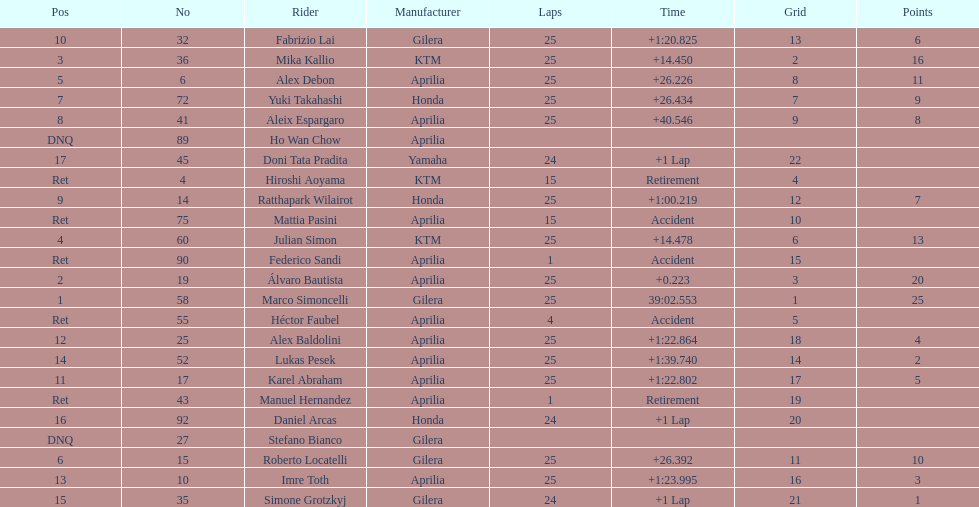Could you parse the entire table as a dict? {'header': ['Pos', 'No', 'Rider', 'Manufacturer', 'Laps', 'Time', 'Grid', 'Points'], 'rows': [['10', '32', 'Fabrizio Lai', 'Gilera', '25', '+1:20.825', '13', '6'], ['3', '36', 'Mika Kallio', 'KTM', '25', '+14.450', '2', '16'], ['5', '6', 'Alex Debon', 'Aprilia', '25', '+26.226', '8', '11'], ['7', '72', 'Yuki Takahashi', 'Honda', '25', '+26.434', '7', '9'], ['8', '41', 'Aleix Espargaro', 'Aprilia', '25', '+40.546', '9', '8'], ['DNQ', '89', 'Ho Wan Chow', 'Aprilia', '', '', '', ''], ['17', '45', 'Doni Tata Pradita', 'Yamaha', '24', '+1 Lap', '22', ''], ['Ret', '4', 'Hiroshi Aoyama', 'KTM', '15', 'Retirement', '4', ''], ['9', '14', 'Ratthapark Wilairot', 'Honda', '25', '+1:00.219', '12', '7'], ['Ret', '75', 'Mattia Pasini', 'Aprilia', '15', 'Accident', '10', ''], ['4', '60', 'Julian Simon', 'KTM', '25', '+14.478', '6', '13'], ['Ret', '90', 'Federico Sandi', 'Aprilia', '1', 'Accident', '15', ''], ['2', '19', 'Álvaro Bautista', 'Aprilia', '25', '+0.223', '3', '20'], ['1', '58', 'Marco Simoncelli', 'Gilera', '25', '39:02.553', '1', '25'], ['Ret', '55', 'Héctor Faubel', 'Aprilia', '4', 'Accident', '5', ''], ['12', '25', 'Alex Baldolini', 'Aprilia', '25', '+1:22.864', '18', '4'], ['14', '52', 'Lukas Pesek', 'Aprilia', '25', '+1:39.740', '14', '2'], ['11', '17', 'Karel Abraham', 'Aprilia', '25', '+1:22.802', '17', '5'], ['Ret', '43', 'Manuel Hernandez', 'Aprilia', '1', 'Retirement', '19', ''], ['16', '92', 'Daniel Arcas', 'Honda', '24', '+1 Lap', '20', ''], ['DNQ', '27', 'Stefano Bianco', 'Gilera', '', '', '', ''], ['6', '15', 'Roberto Locatelli', 'Gilera', '25', '+26.392', '11', '10'], ['13', '10', 'Imre Toth', 'Aprilia', '25', '+1:23.995', '16', '3'], ['15', '35', 'Simone Grotzkyj', 'Gilera', '24', '+1 Lap', '21', '1']]} The country with the most riders was Italy. 